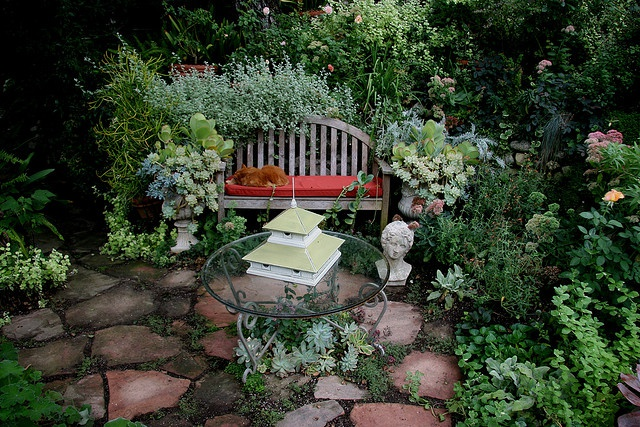Describe the objects in this image and their specific colors. I can see dining table in black, gray, darkgray, and beige tones, potted plant in black, darkgreen, and green tones, bench in black, darkgray, gray, and maroon tones, potted plant in black and darkgreen tones, and potted plant in black, gray, darkgray, and darkgreen tones in this image. 